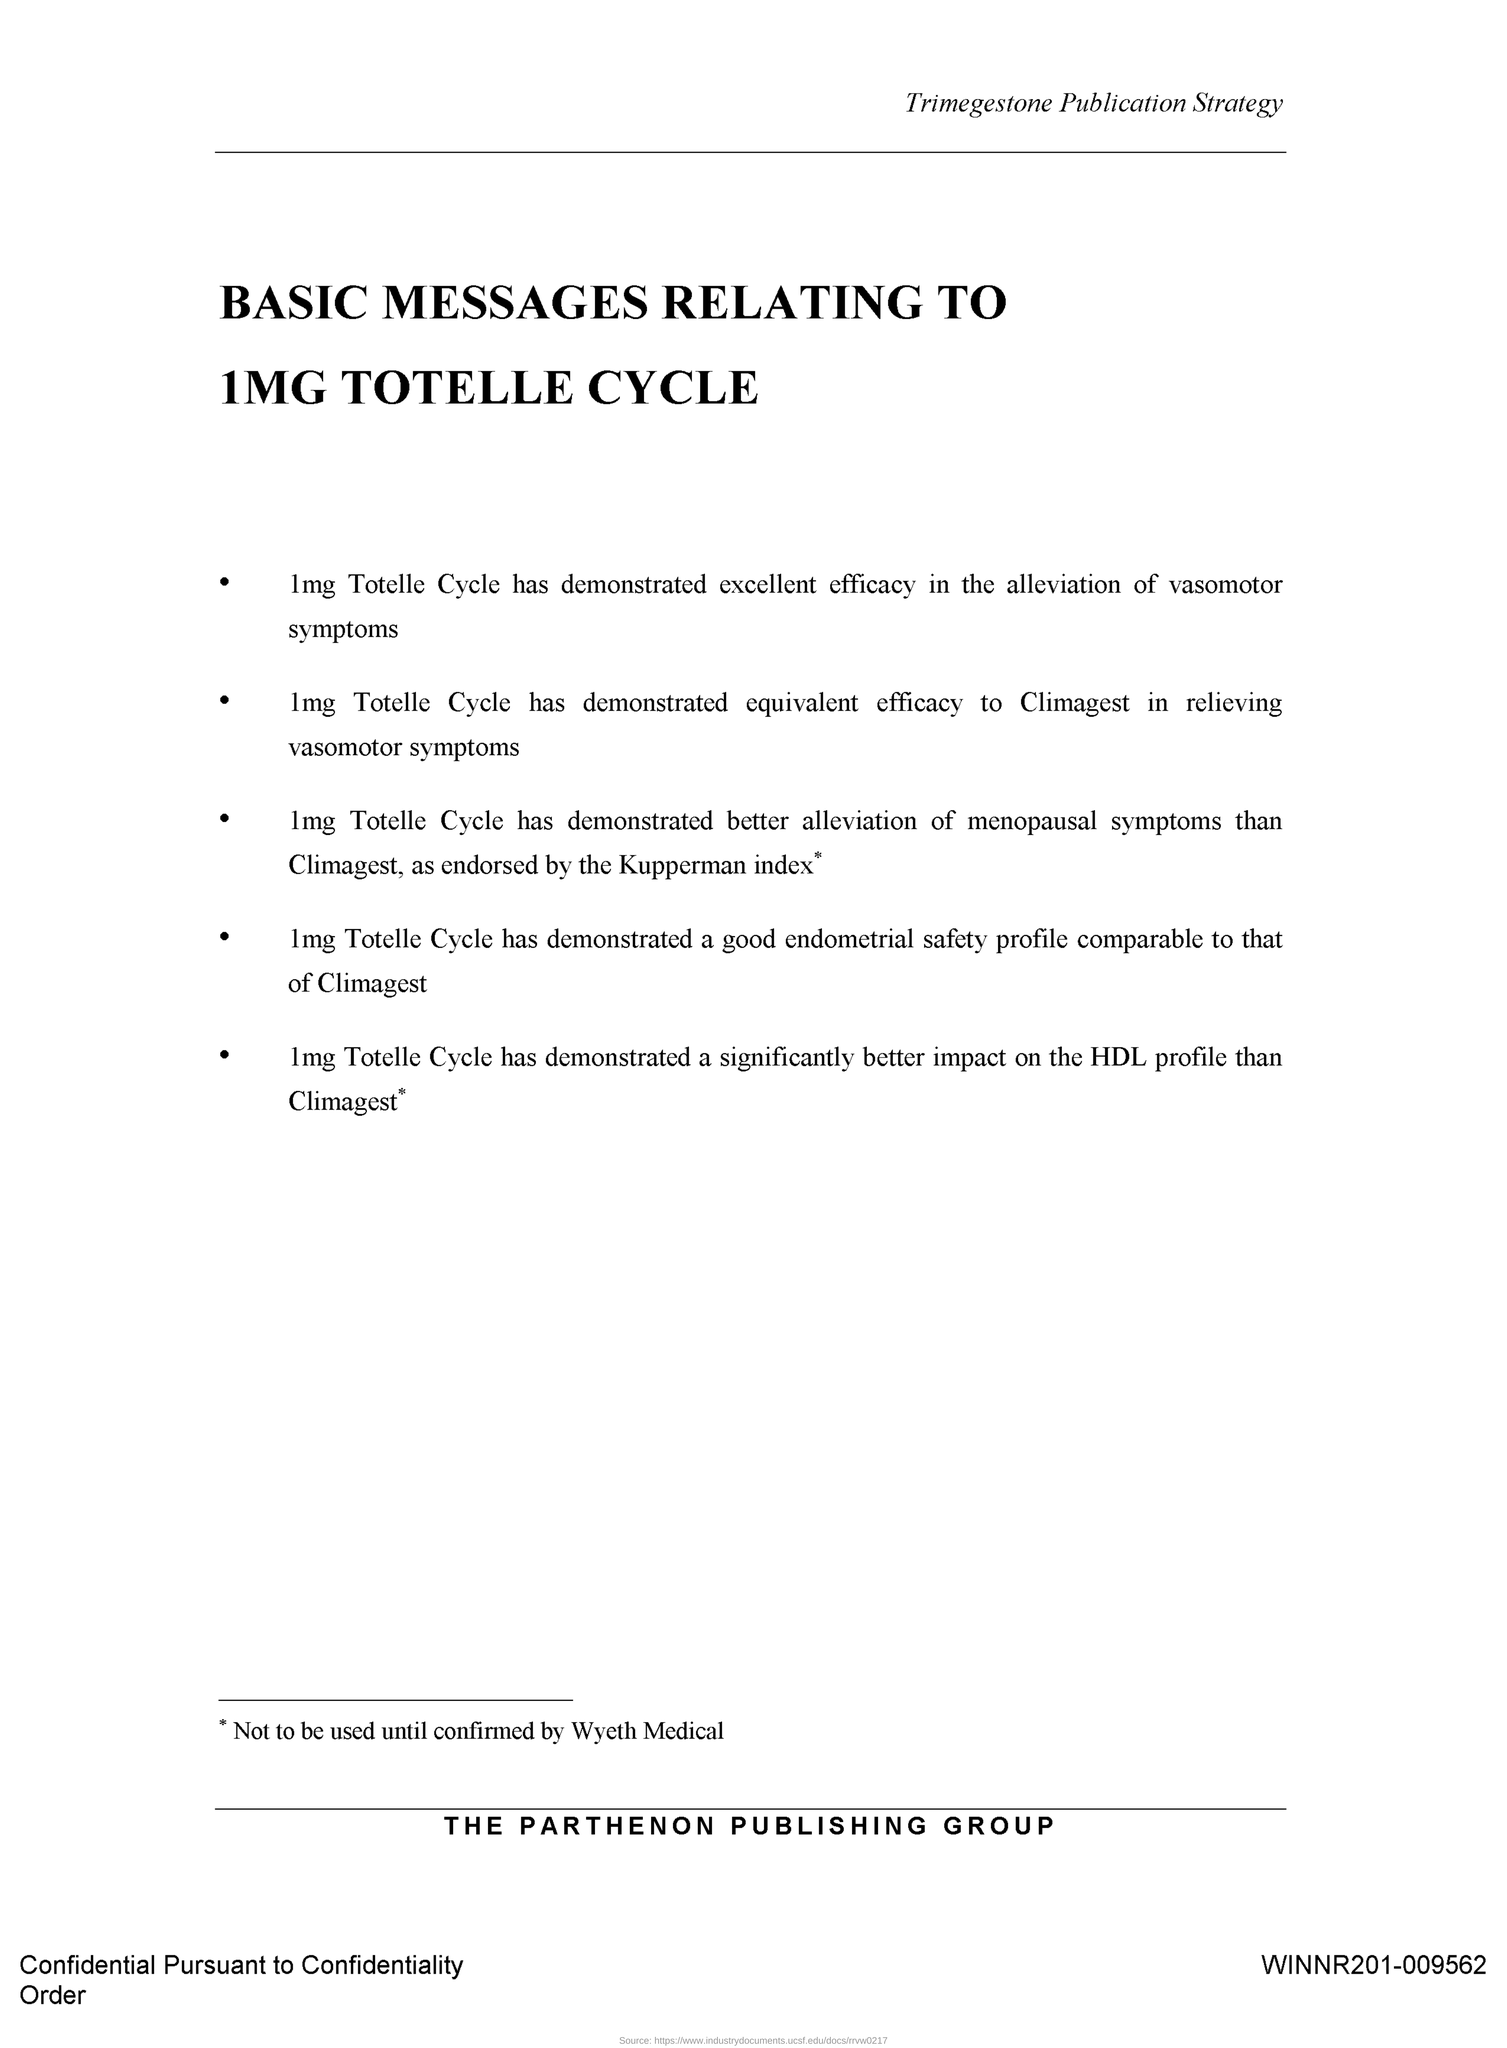What is the title of the document?
Your answer should be very brief. BASIC MESSAGES RELATING TO 1MG TOTELLE CYCLE. 